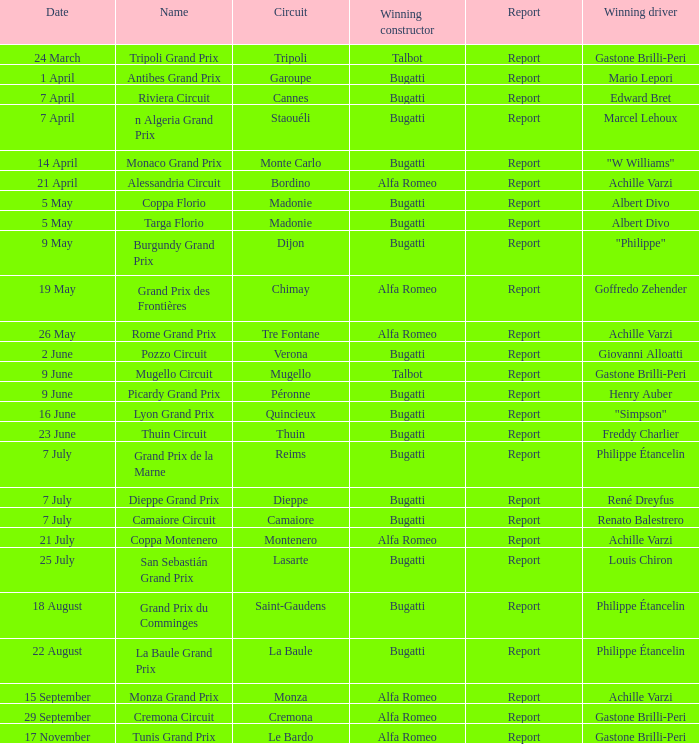What Date has a Name of thuin circuit? 23 June. 